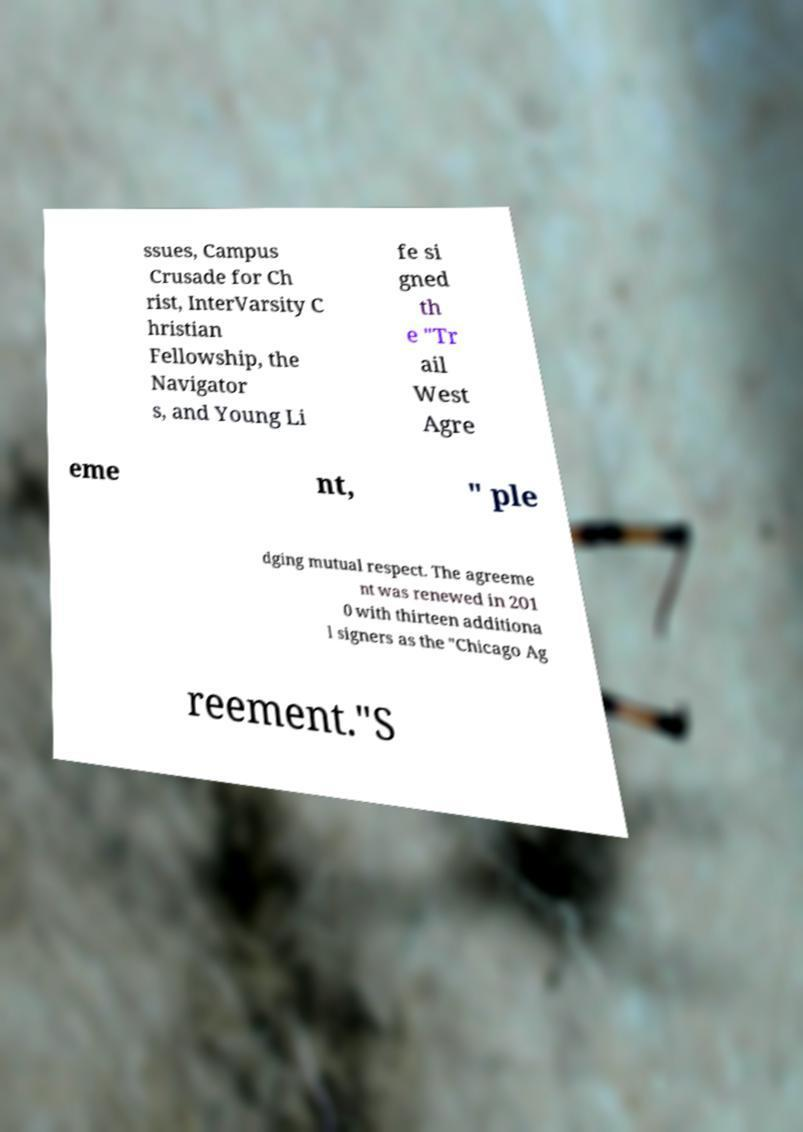Can you accurately transcribe the text from the provided image for me? ssues, Campus Crusade for Ch rist, InterVarsity C hristian Fellowship, the Navigator s, and Young Li fe si gned th e "Tr ail West Agre eme nt, " ple dging mutual respect. The agreeme nt was renewed in 201 0 with thirteen additiona l signers as the "Chicago Ag reement."S 